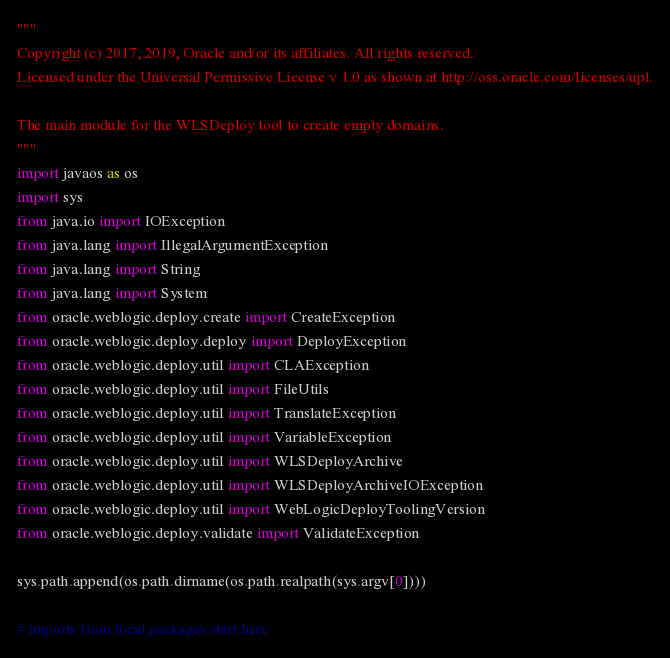Convert code to text. <code><loc_0><loc_0><loc_500><loc_500><_Python_>"""
Copyright (c) 2017, 2019, Oracle and/or its affiliates. All rights reserved.
Licensed under the Universal Permissive License v 1.0 as shown at http://oss.oracle.com/licenses/upl.

The main module for the WLSDeploy tool to create empty domains.
"""
import javaos as os
import sys
from java.io import IOException
from java.lang import IllegalArgumentException
from java.lang import String
from java.lang import System
from oracle.weblogic.deploy.create import CreateException
from oracle.weblogic.deploy.deploy import DeployException
from oracle.weblogic.deploy.util import CLAException
from oracle.weblogic.deploy.util import FileUtils
from oracle.weblogic.deploy.util import TranslateException
from oracle.weblogic.deploy.util import VariableException
from oracle.weblogic.deploy.util import WLSDeployArchive
from oracle.weblogic.deploy.util import WLSDeployArchiveIOException
from oracle.weblogic.deploy.util import WebLogicDeployToolingVersion
from oracle.weblogic.deploy.validate import ValidateException

sys.path.append(os.path.dirname(os.path.realpath(sys.argv[0])))

# imports from local packages start here
</code> 